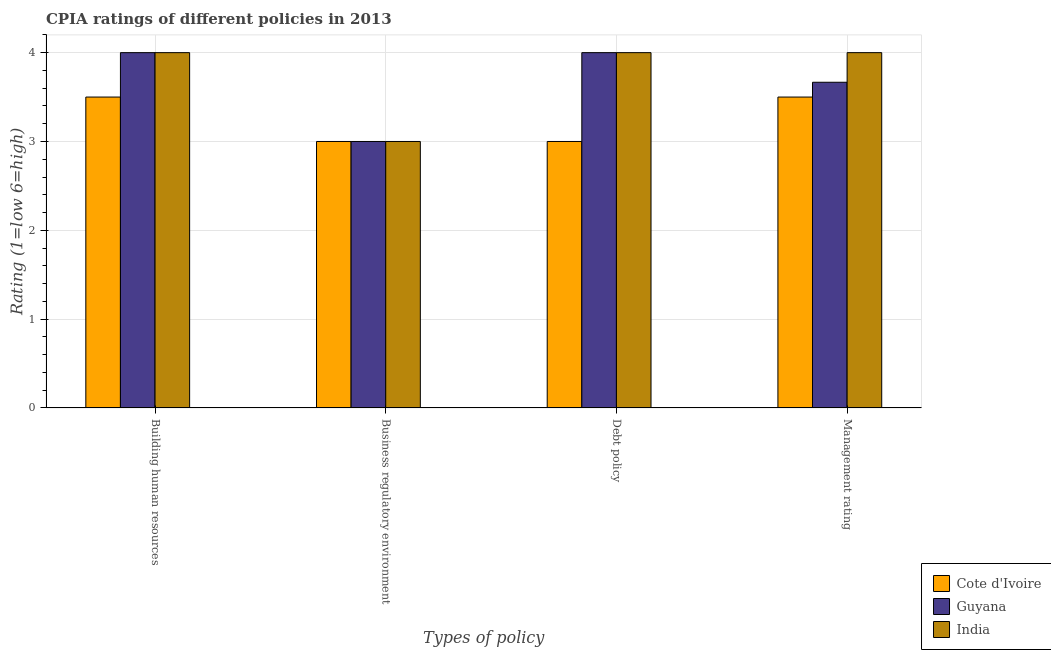Are the number of bars per tick equal to the number of legend labels?
Keep it short and to the point. Yes. Are the number of bars on each tick of the X-axis equal?
Your answer should be very brief. Yes. How many bars are there on the 1st tick from the right?
Give a very brief answer. 3. What is the label of the 3rd group of bars from the left?
Offer a very short reply. Debt policy. Across all countries, what is the maximum cpia rating of business regulatory environment?
Offer a terse response. 3. Across all countries, what is the minimum cpia rating of building human resources?
Provide a succinct answer. 3.5. In which country was the cpia rating of building human resources maximum?
Your answer should be compact. Guyana. In which country was the cpia rating of business regulatory environment minimum?
Provide a short and direct response. Cote d'Ivoire. What is the total cpia rating of business regulatory environment in the graph?
Make the answer very short. 9. What is the difference between the cpia rating of management in Cote d'Ivoire and that in Guyana?
Provide a succinct answer. -0.17. What is the average cpia rating of building human resources per country?
Your answer should be very brief. 3.83. What is the difference between the cpia rating of management and cpia rating of building human resources in India?
Offer a very short reply. 0. What is the ratio of the cpia rating of business regulatory environment in Guyana to that in India?
Offer a very short reply. 1. Is the cpia rating of debt policy in India less than that in Cote d'Ivoire?
Your answer should be very brief. No. What does the 1st bar from the left in Management rating represents?
Your answer should be compact. Cote d'Ivoire. What does the 3rd bar from the right in Management rating represents?
Provide a succinct answer. Cote d'Ivoire. Is it the case that in every country, the sum of the cpia rating of building human resources and cpia rating of business regulatory environment is greater than the cpia rating of debt policy?
Provide a short and direct response. Yes. How many countries are there in the graph?
Your answer should be compact. 3. Where does the legend appear in the graph?
Ensure brevity in your answer.  Bottom right. How are the legend labels stacked?
Your response must be concise. Vertical. What is the title of the graph?
Your response must be concise. CPIA ratings of different policies in 2013. What is the label or title of the X-axis?
Offer a very short reply. Types of policy. What is the label or title of the Y-axis?
Your answer should be very brief. Rating (1=low 6=high). What is the Rating (1=low 6=high) of Cote d'Ivoire in Building human resources?
Offer a very short reply. 3.5. What is the Rating (1=low 6=high) of India in Building human resources?
Ensure brevity in your answer.  4. What is the Rating (1=low 6=high) in India in Business regulatory environment?
Make the answer very short. 3. What is the Rating (1=low 6=high) in Guyana in Debt policy?
Provide a succinct answer. 4. What is the Rating (1=low 6=high) of India in Debt policy?
Your response must be concise. 4. What is the Rating (1=low 6=high) of Cote d'Ivoire in Management rating?
Offer a very short reply. 3.5. What is the Rating (1=low 6=high) in Guyana in Management rating?
Your response must be concise. 3.67. What is the Rating (1=low 6=high) in India in Management rating?
Provide a succinct answer. 4. Across all Types of policy, what is the maximum Rating (1=low 6=high) in Cote d'Ivoire?
Offer a terse response. 3.5. Across all Types of policy, what is the maximum Rating (1=low 6=high) in Guyana?
Keep it short and to the point. 4. Across all Types of policy, what is the minimum Rating (1=low 6=high) of India?
Provide a succinct answer. 3. What is the total Rating (1=low 6=high) in Cote d'Ivoire in the graph?
Your response must be concise. 13. What is the total Rating (1=low 6=high) in Guyana in the graph?
Your answer should be compact. 14.67. What is the total Rating (1=low 6=high) of India in the graph?
Give a very brief answer. 15. What is the difference between the Rating (1=low 6=high) in Cote d'Ivoire in Building human resources and that in Business regulatory environment?
Ensure brevity in your answer.  0.5. What is the difference between the Rating (1=low 6=high) of Guyana in Building human resources and that in Debt policy?
Your answer should be compact. 0. What is the difference between the Rating (1=low 6=high) in India in Building human resources and that in Debt policy?
Provide a short and direct response. 0. What is the difference between the Rating (1=low 6=high) of Guyana in Building human resources and that in Management rating?
Give a very brief answer. 0.33. What is the difference between the Rating (1=low 6=high) of India in Building human resources and that in Management rating?
Provide a succinct answer. 0. What is the difference between the Rating (1=low 6=high) of Cote d'Ivoire in Business regulatory environment and that in Debt policy?
Offer a very short reply. 0. What is the difference between the Rating (1=low 6=high) of Guyana in Business regulatory environment and that in Debt policy?
Offer a very short reply. -1. What is the difference between the Rating (1=low 6=high) of India in Business regulatory environment and that in Debt policy?
Keep it short and to the point. -1. What is the difference between the Rating (1=low 6=high) of Cote d'Ivoire in Business regulatory environment and that in Management rating?
Provide a short and direct response. -0.5. What is the difference between the Rating (1=low 6=high) in Guyana in Business regulatory environment and that in Management rating?
Provide a succinct answer. -0.67. What is the difference between the Rating (1=low 6=high) in Cote d'Ivoire in Debt policy and that in Management rating?
Offer a terse response. -0.5. What is the difference between the Rating (1=low 6=high) in Guyana in Debt policy and that in Management rating?
Give a very brief answer. 0.33. What is the difference between the Rating (1=low 6=high) of India in Debt policy and that in Management rating?
Make the answer very short. 0. What is the difference between the Rating (1=low 6=high) of Guyana in Building human resources and the Rating (1=low 6=high) of India in Management rating?
Make the answer very short. 0. What is the difference between the Rating (1=low 6=high) in Cote d'Ivoire in Business regulatory environment and the Rating (1=low 6=high) in Guyana in Debt policy?
Offer a very short reply. -1. What is the difference between the Rating (1=low 6=high) of Guyana in Business regulatory environment and the Rating (1=low 6=high) of India in Debt policy?
Give a very brief answer. -1. What is the difference between the Rating (1=low 6=high) in Guyana in Business regulatory environment and the Rating (1=low 6=high) in India in Management rating?
Provide a short and direct response. -1. What is the average Rating (1=low 6=high) of Guyana per Types of policy?
Your answer should be compact. 3.67. What is the average Rating (1=low 6=high) of India per Types of policy?
Your response must be concise. 3.75. What is the difference between the Rating (1=low 6=high) of Cote d'Ivoire and Rating (1=low 6=high) of Guyana in Building human resources?
Your response must be concise. -0.5. What is the difference between the Rating (1=low 6=high) of Guyana and Rating (1=low 6=high) of India in Building human resources?
Offer a very short reply. 0. What is the difference between the Rating (1=low 6=high) of Cote d'Ivoire and Rating (1=low 6=high) of Guyana in Debt policy?
Offer a very short reply. -1. What is the difference between the Rating (1=low 6=high) of Cote d'Ivoire and Rating (1=low 6=high) of India in Debt policy?
Make the answer very short. -1. What is the difference between the Rating (1=low 6=high) of Cote d'Ivoire and Rating (1=low 6=high) of Guyana in Management rating?
Offer a terse response. -0.17. What is the difference between the Rating (1=low 6=high) in Guyana and Rating (1=low 6=high) in India in Management rating?
Provide a succinct answer. -0.33. What is the ratio of the Rating (1=low 6=high) in Cote d'Ivoire in Building human resources to that in Debt policy?
Your answer should be compact. 1.17. What is the ratio of the Rating (1=low 6=high) of Guyana in Building human resources to that in Debt policy?
Your answer should be compact. 1. What is the ratio of the Rating (1=low 6=high) in India in Building human resources to that in Debt policy?
Give a very brief answer. 1. What is the ratio of the Rating (1=low 6=high) in Cote d'Ivoire in Building human resources to that in Management rating?
Provide a short and direct response. 1. What is the ratio of the Rating (1=low 6=high) in India in Building human resources to that in Management rating?
Make the answer very short. 1. What is the ratio of the Rating (1=low 6=high) in Cote d'Ivoire in Business regulatory environment to that in Debt policy?
Make the answer very short. 1. What is the ratio of the Rating (1=low 6=high) of Cote d'Ivoire in Business regulatory environment to that in Management rating?
Ensure brevity in your answer.  0.86. What is the ratio of the Rating (1=low 6=high) in Guyana in Business regulatory environment to that in Management rating?
Your response must be concise. 0.82. What is the ratio of the Rating (1=low 6=high) in Cote d'Ivoire in Debt policy to that in Management rating?
Provide a short and direct response. 0.86. What is the ratio of the Rating (1=low 6=high) of Guyana in Debt policy to that in Management rating?
Your answer should be very brief. 1.09. What is the ratio of the Rating (1=low 6=high) of India in Debt policy to that in Management rating?
Offer a very short reply. 1. 